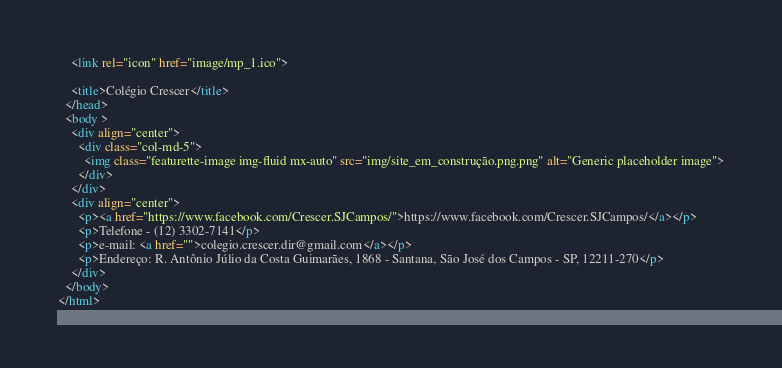<code> <loc_0><loc_0><loc_500><loc_500><_HTML_>    <link rel="icon" href="image/mp_1.ico">

    <title>Colégio Crescer</title>
  </head>
  <body >
    <div align="center">
      <div class="col-md-5">
        <img class="featurette-image img-fluid mx-auto" src="img/site_em_construção.png.png" alt="Generic placeholder image">
      </div>
    </div>
    <div align="center">
      <p><a href="https://www.facebook.com/Crescer.SJCampos/">https://www.facebook.com/Crescer.SJCampos/</a></p>
      <p>Telefone - (12) 3302-7141</p>
      <p>e-mail: <a href="">colegio.crescer.dir@gmail.com</a></p>
      <p>Endereço: R. Antônio Júlio da Costa Guimarães, 1868 - Santana, São José dos Campos - SP, 12211-270</p>
    </div>
  </body>
</html></code> 